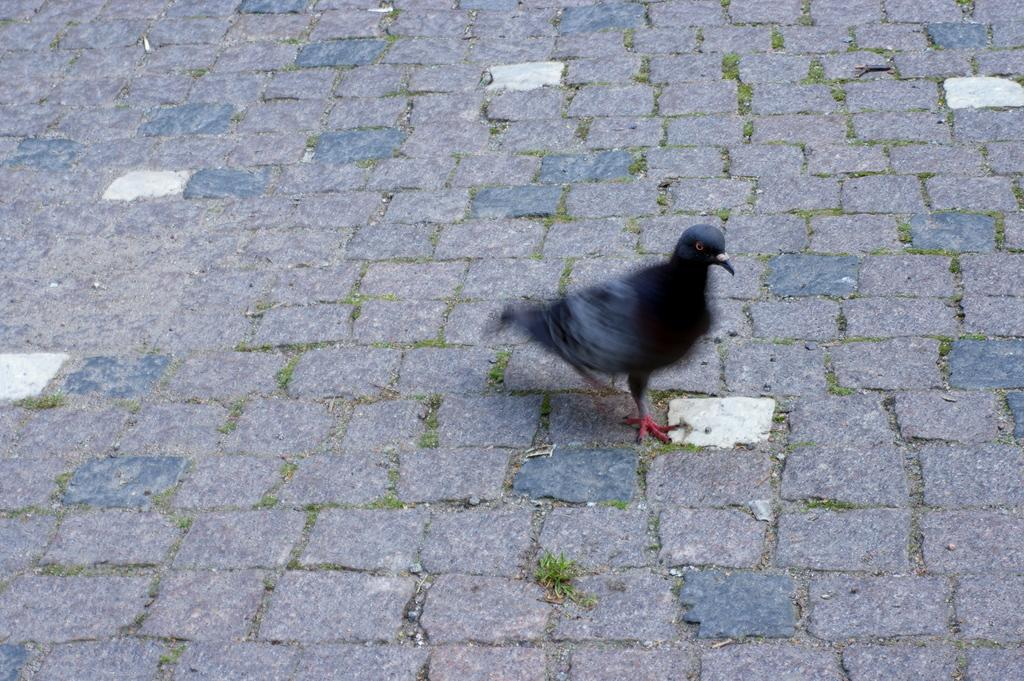What is the main subject in the center of the image? There is a pigeon in the center of the image. What can be seen at the bottom of the image? There is a walkway at the bottom of the image. What theory is the pigeon proposing in the image? There is no indication in the image that the pigeon is proposing a theory or making any suggestions. 